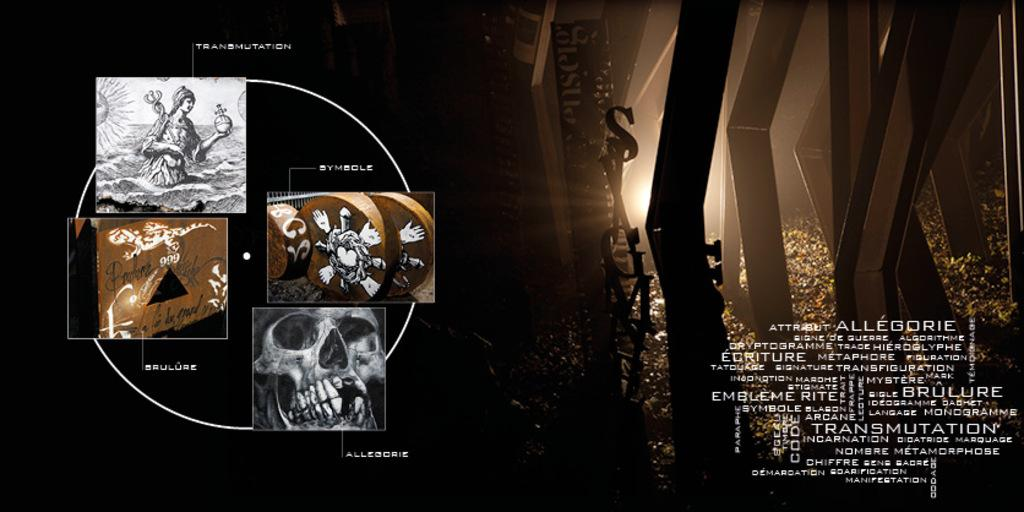<image>
Provide a brief description of the given image. An advertising poster for Attribut Allegorie showing different stages on the left and woods on the right.. 